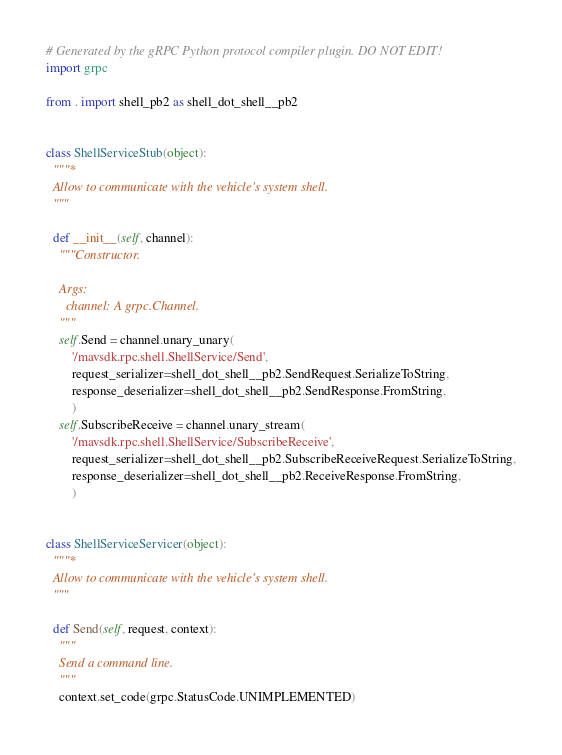Convert code to text. <code><loc_0><loc_0><loc_500><loc_500><_Python_># Generated by the gRPC Python protocol compiler plugin. DO NOT EDIT!
import grpc

from . import shell_pb2 as shell_dot_shell__pb2


class ShellServiceStub(object):
  """*
  Allow to communicate with the vehicle's system shell.
  """

  def __init__(self, channel):
    """Constructor.

    Args:
      channel: A grpc.Channel.
    """
    self.Send = channel.unary_unary(
        '/mavsdk.rpc.shell.ShellService/Send',
        request_serializer=shell_dot_shell__pb2.SendRequest.SerializeToString,
        response_deserializer=shell_dot_shell__pb2.SendResponse.FromString,
        )
    self.SubscribeReceive = channel.unary_stream(
        '/mavsdk.rpc.shell.ShellService/SubscribeReceive',
        request_serializer=shell_dot_shell__pb2.SubscribeReceiveRequest.SerializeToString,
        response_deserializer=shell_dot_shell__pb2.ReceiveResponse.FromString,
        )


class ShellServiceServicer(object):
  """*
  Allow to communicate with the vehicle's system shell.
  """

  def Send(self, request, context):
    """
    Send a command line.
    """
    context.set_code(grpc.StatusCode.UNIMPLEMENTED)</code> 